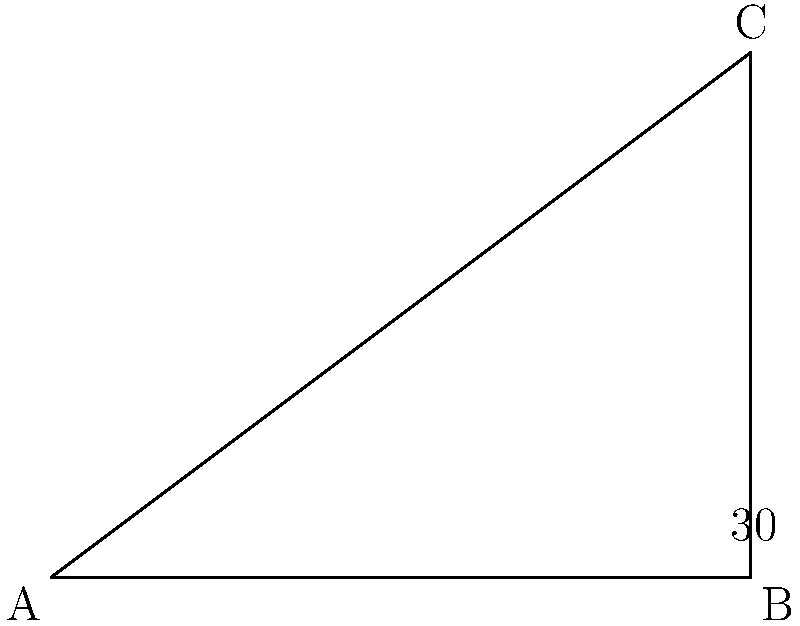In the right triangle ABC shown above, angle B is a right angle (90°) and angle C measures 30°. Write a Python function to calculate the measure of angle A, which is the complementary angle to angle C. Let's break this down step-by-step:

1. In a right triangle, we know that the sum of all angles is 180°.

2. We're given that angle B is 90° (right angle) and angle C is 30°.

3. To find angle A, we can subtract the known angles from 180°:
   $$A = 180° - 90° - 30° = 60°$$

4. Now, let's write a Python function to calculate this:

```python
def calculate_complementary_angle(given_angle):
    right_angle = 90
    total_angles = 180
    complementary_angle = total_angles - right_angle - given_angle
    return complementary_angle

# Test the function
result = calculate_complementary_angle(30)
print(f"The complementary angle is {result} degrees")
```

5. This function takes the given angle as an input, subtracts it and the right angle (90°) from the total (180°), and returns the result.

6. When we run this function with the given angle of 30°, it will return 60°, which is the measure of angle A.
Answer: 60° 